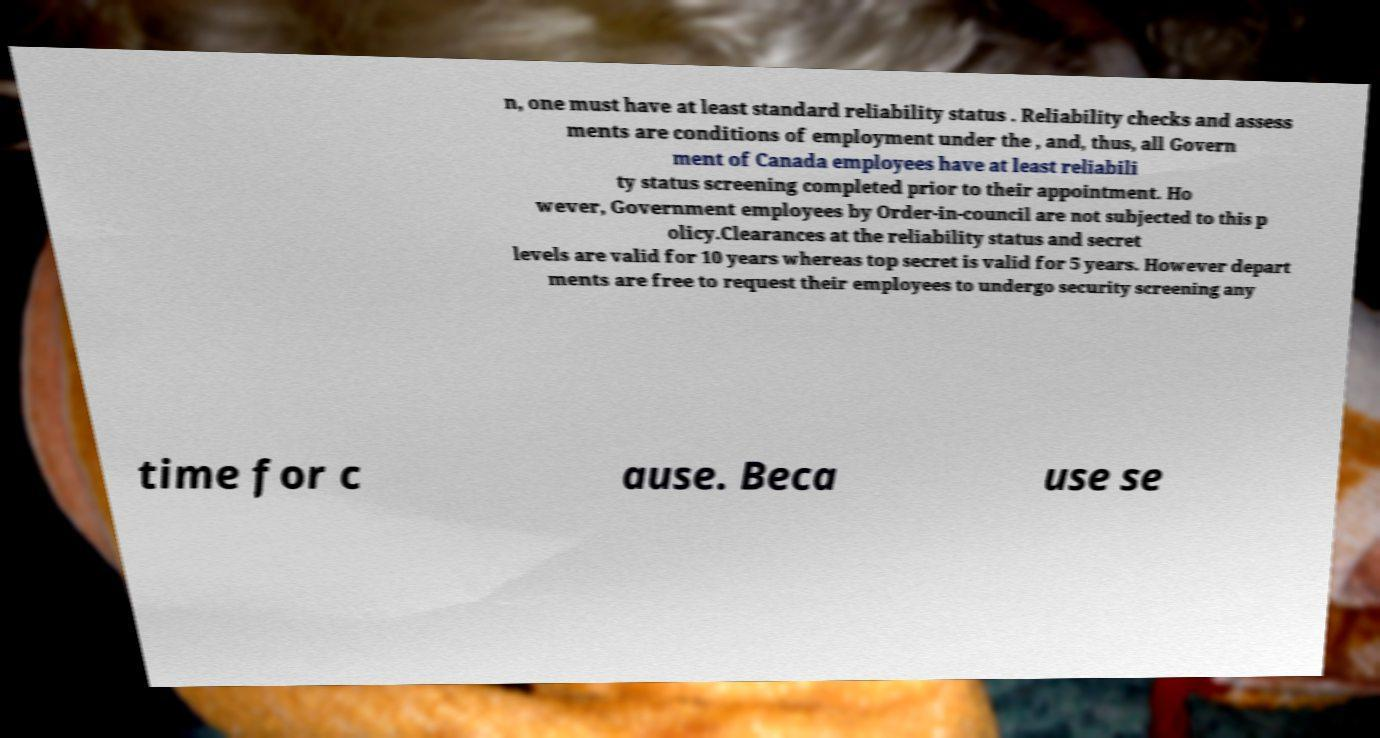There's text embedded in this image that I need extracted. Can you transcribe it verbatim? n, one must have at least standard reliability status . Reliability checks and assess ments are conditions of employment under the , and, thus, all Govern ment of Canada employees have at least reliabili ty status screening completed prior to their appointment. Ho wever, Government employees by Order-in-council are not subjected to this p olicy.Clearances at the reliability status and secret levels are valid for 10 years whereas top secret is valid for 5 years. However depart ments are free to request their employees to undergo security screening any time for c ause. Beca use se 